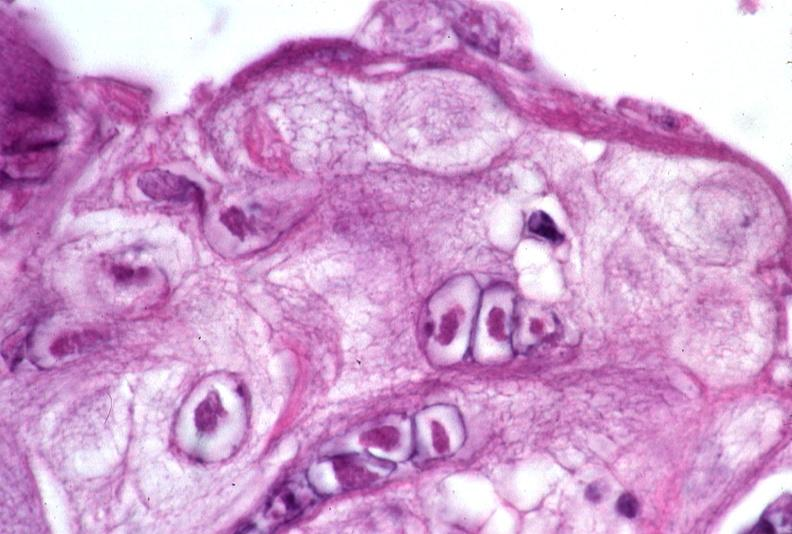what does this image show?
Answer the question using a single word or phrase. Skin 